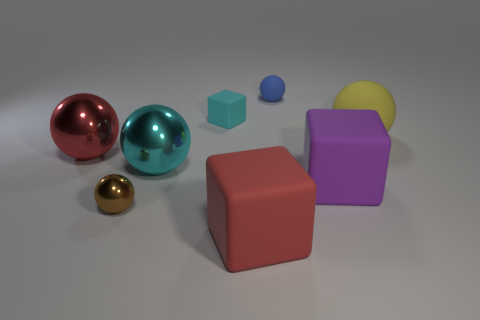How many metal things are either red spheres or brown things?
Ensure brevity in your answer.  2. What is the size of the cyan rubber object?
Keep it short and to the point. Small. How many objects are tiny things or big red objects on the right side of the small cyan thing?
Make the answer very short. 4. What number of other objects are the same color as the small metal object?
Your response must be concise. 0. There is a yellow sphere; is its size the same as the red object behind the small metallic object?
Offer a terse response. Yes. Do the metal object that is left of the brown metallic ball and the cyan metallic thing have the same size?
Make the answer very short. Yes. How many other things are the same material as the tiny brown thing?
Keep it short and to the point. 2. Are there the same number of blue balls that are in front of the yellow matte ball and shiny things that are behind the blue rubber sphere?
Keep it short and to the point. Yes. There is a tiny object on the left side of the tiny rubber object that is in front of the sphere behind the yellow ball; what color is it?
Offer a very short reply. Brown. The small thing in front of the purple matte block has what shape?
Your response must be concise. Sphere. 